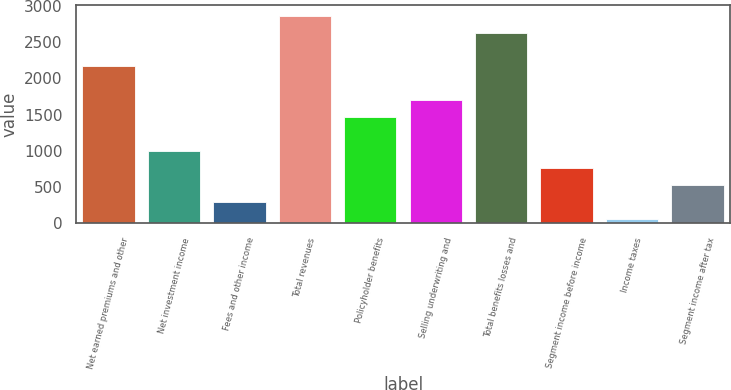<chart> <loc_0><loc_0><loc_500><loc_500><bar_chart><fcel>Net earned premiums and other<fcel>Net investment income<fcel>Fees and other income<fcel>Total revenues<fcel>Policyholder benefits<fcel>Selling underwriting and<fcel>Total benefits losses and<fcel>Segment income before income<fcel>Income taxes<fcel>Segment income after tax<nl><fcel>2167.4<fcel>999.4<fcel>298.6<fcel>2868.2<fcel>1466.6<fcel>1700.2<fcel>2634.6<fcel>765.8<fcel>65<fcel>532.2<nl></chart> 